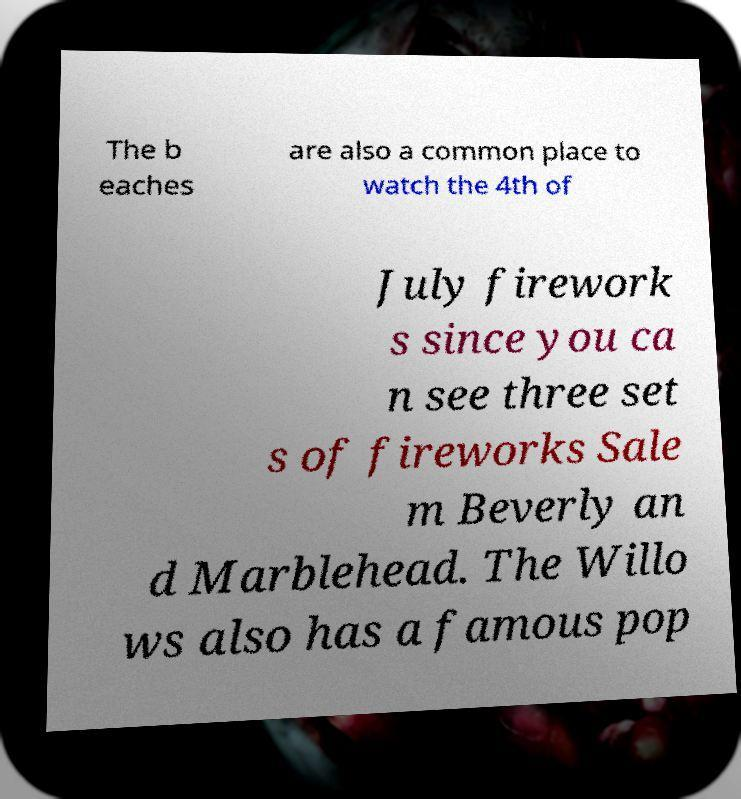For documentation purposes, I need the text within this image transcribed. Could you provide that? The b eaches are also a common place to watch the 4th of July firework s since you ca n see three set s of fireworks Sale m Beverly an d Marblehead. The Willo ws also has a famous pop 